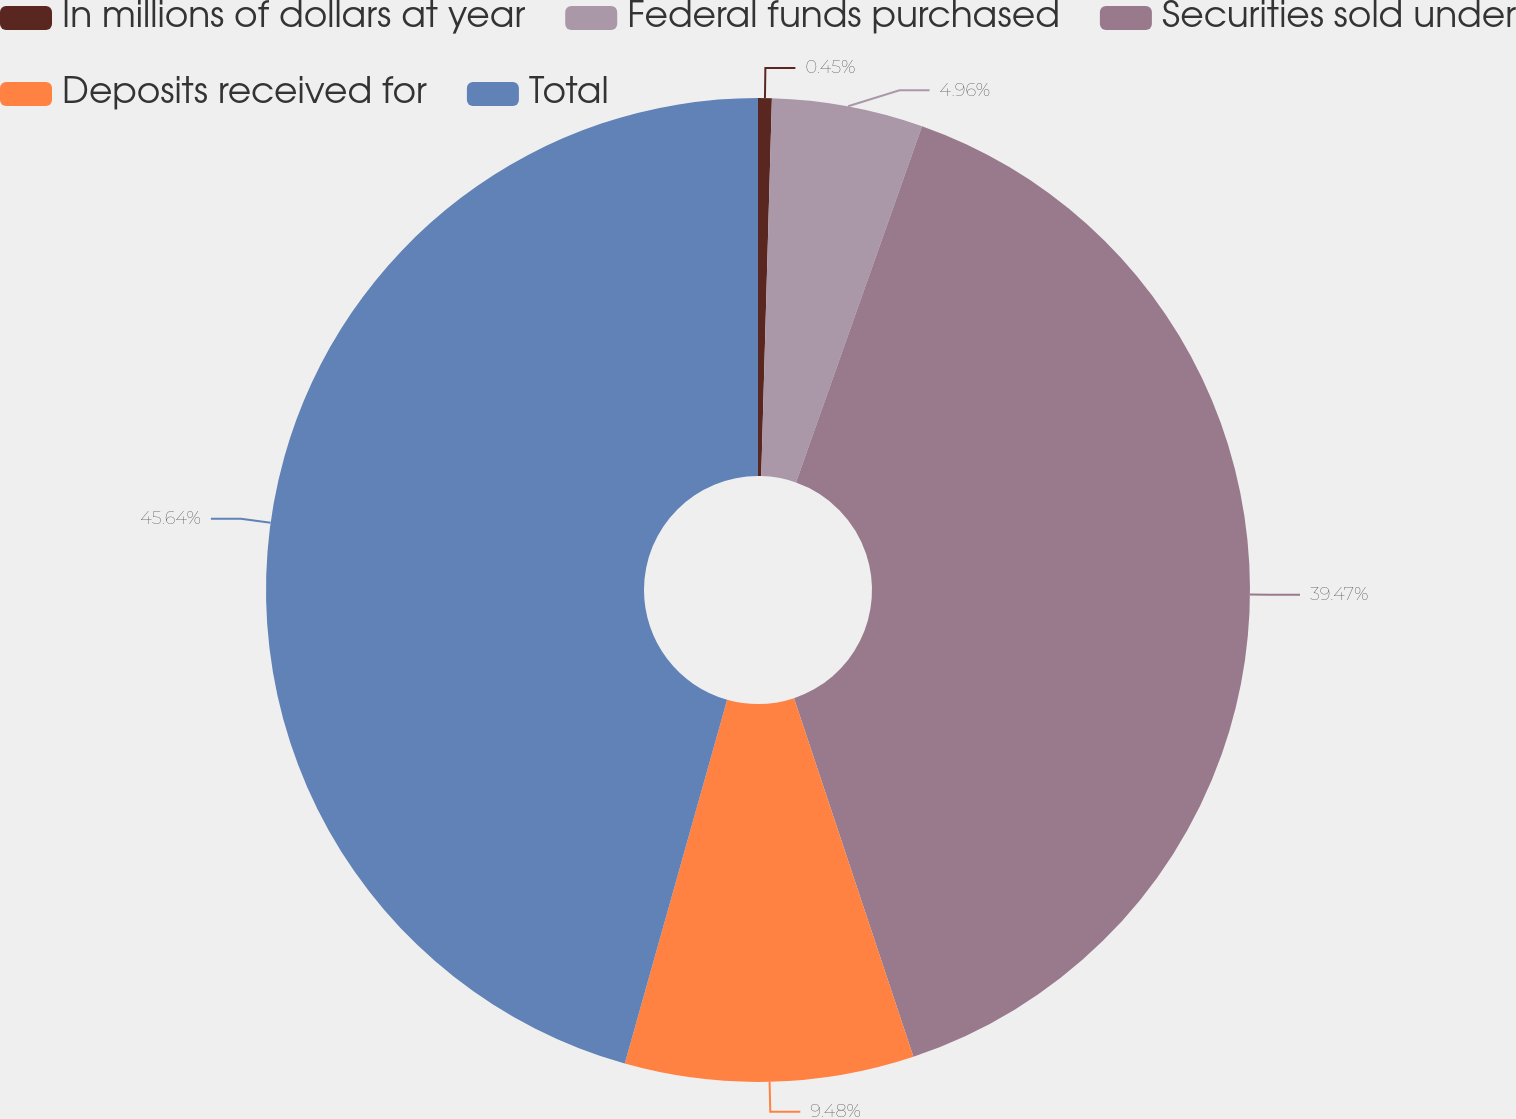Convert chart. <chart><loc_0><loc_0><loc_500><loc_500><pie_chart><fcel>In millions of dollars at year<fcel>Federal funds purchased<fcel>Securities sold under<fcel>Deposits received for<fcel>Total<nl><fcel>0.45%<fcel>4.96%<fcel>39.47%<fcel>9.48%<fcel>45.63%<nl></chart> 